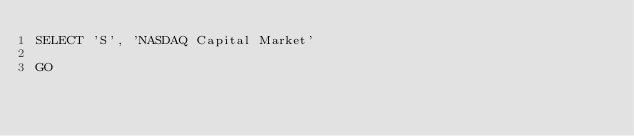<code> <loc_0><loc_0><loc_500><loc_500><_SQL_>SELECT 'S', 'NASDAQ Capital Market'

GO</code> 